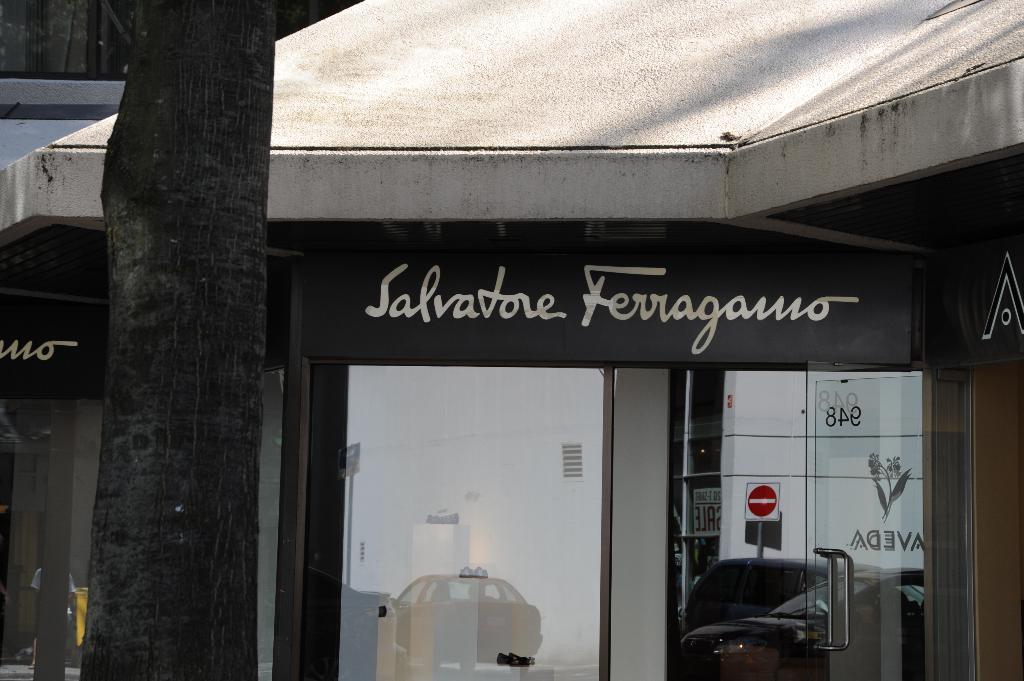Describe this image in one or two sentences. In this image we can see a building with a signboard with some text on it, windows and a door. In the foreground we can see a tree. 